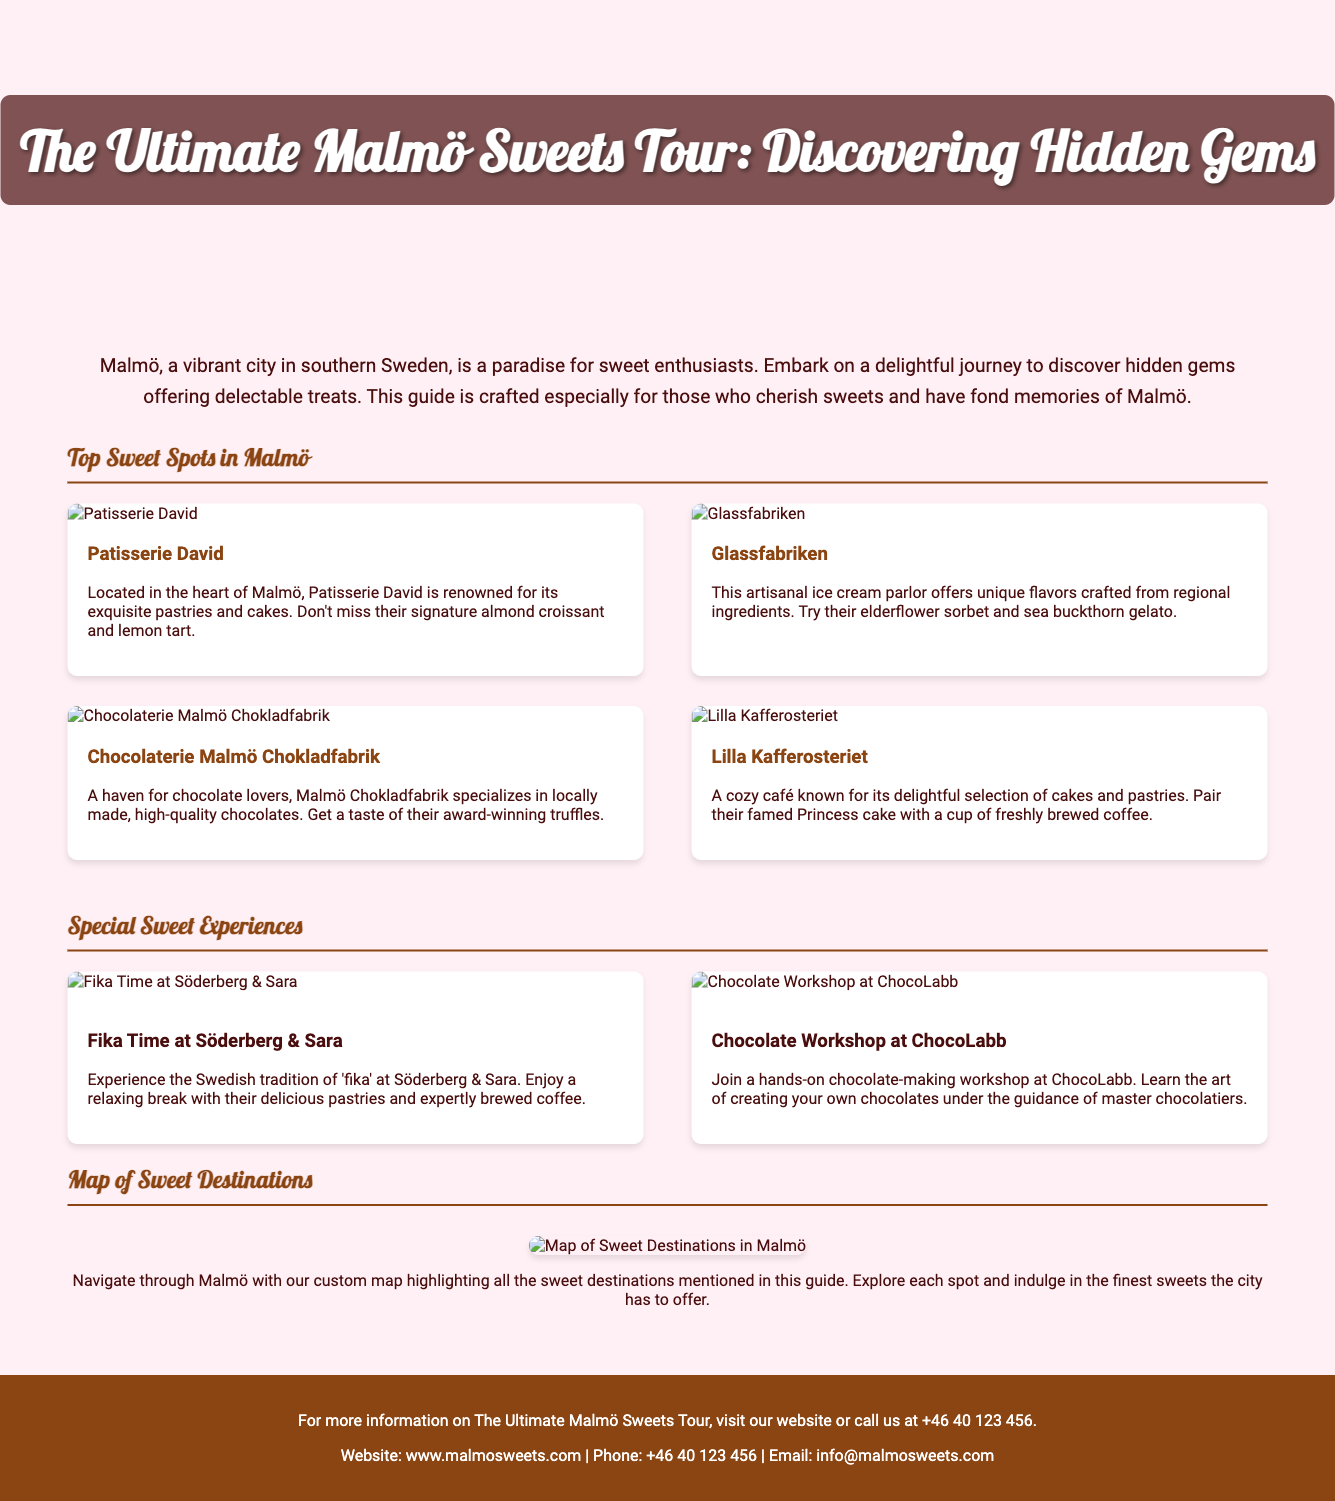What is the title of the tour? The title of the tour is mentioned prominently at the top of the flyer.
Answer: The Ultimate Malmö Sweets Tour: Discovering Hidden Gems How many sweet spots are listed? The document lists four sweet spots under the "Top Sweet Spots in Malmö" section.
Answer: Four What is the signature item at Patisserie David? The document specifies what to not miss at Patisserie David.
Answer: Almond croissant What unique flavor does Glassfabriken offer? The document provides examples of unique flavors offered at Glassfabriken.
Answer: Elderflower sorbet What type of experience does ChocoLabb offer? The document describes the type of workshop available at ChocoLabb.
Answer: Chocolate-making workshop Which café is known for its Princess cake? The document indicates which café pairs their special cake with freshly brewed coffee.
Answer: Lilla Kafferosteriet What is the contact phone number for more information? The phone number provided in the footer for queries is part of the document details.
Answer: +46 40 123 456 What is the main theme of the tour? The intro paragraph summarizes the purpose of the tour.
Answer: Discovering hidden gems offering delectable treats What form of tradition is experienced at Söderberg & Sara? The document explicitly mentions the cultural tradition guests can experience there.
Answer: Fika 